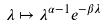Convert formula to latex. <formula><loc_0><loc_0><loc_500><loc_500>\lambda \mapsto \lambda ^ { \alpha - 1 } e ^ { - \beta \lambda }</formula> 